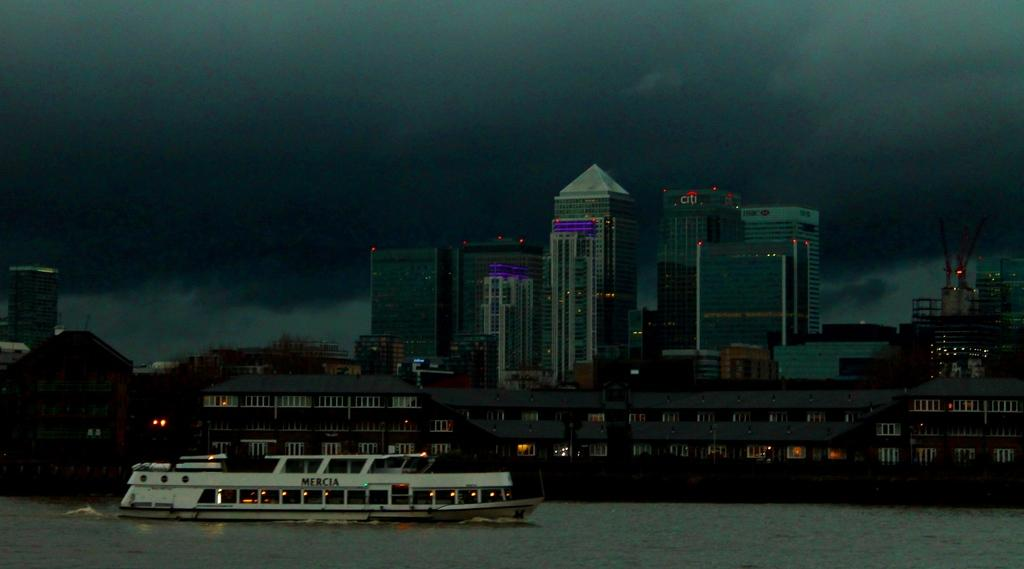<image>
Summarize the visual content of the image. a ferry in the water in front of buildings like CITI and HSBC 